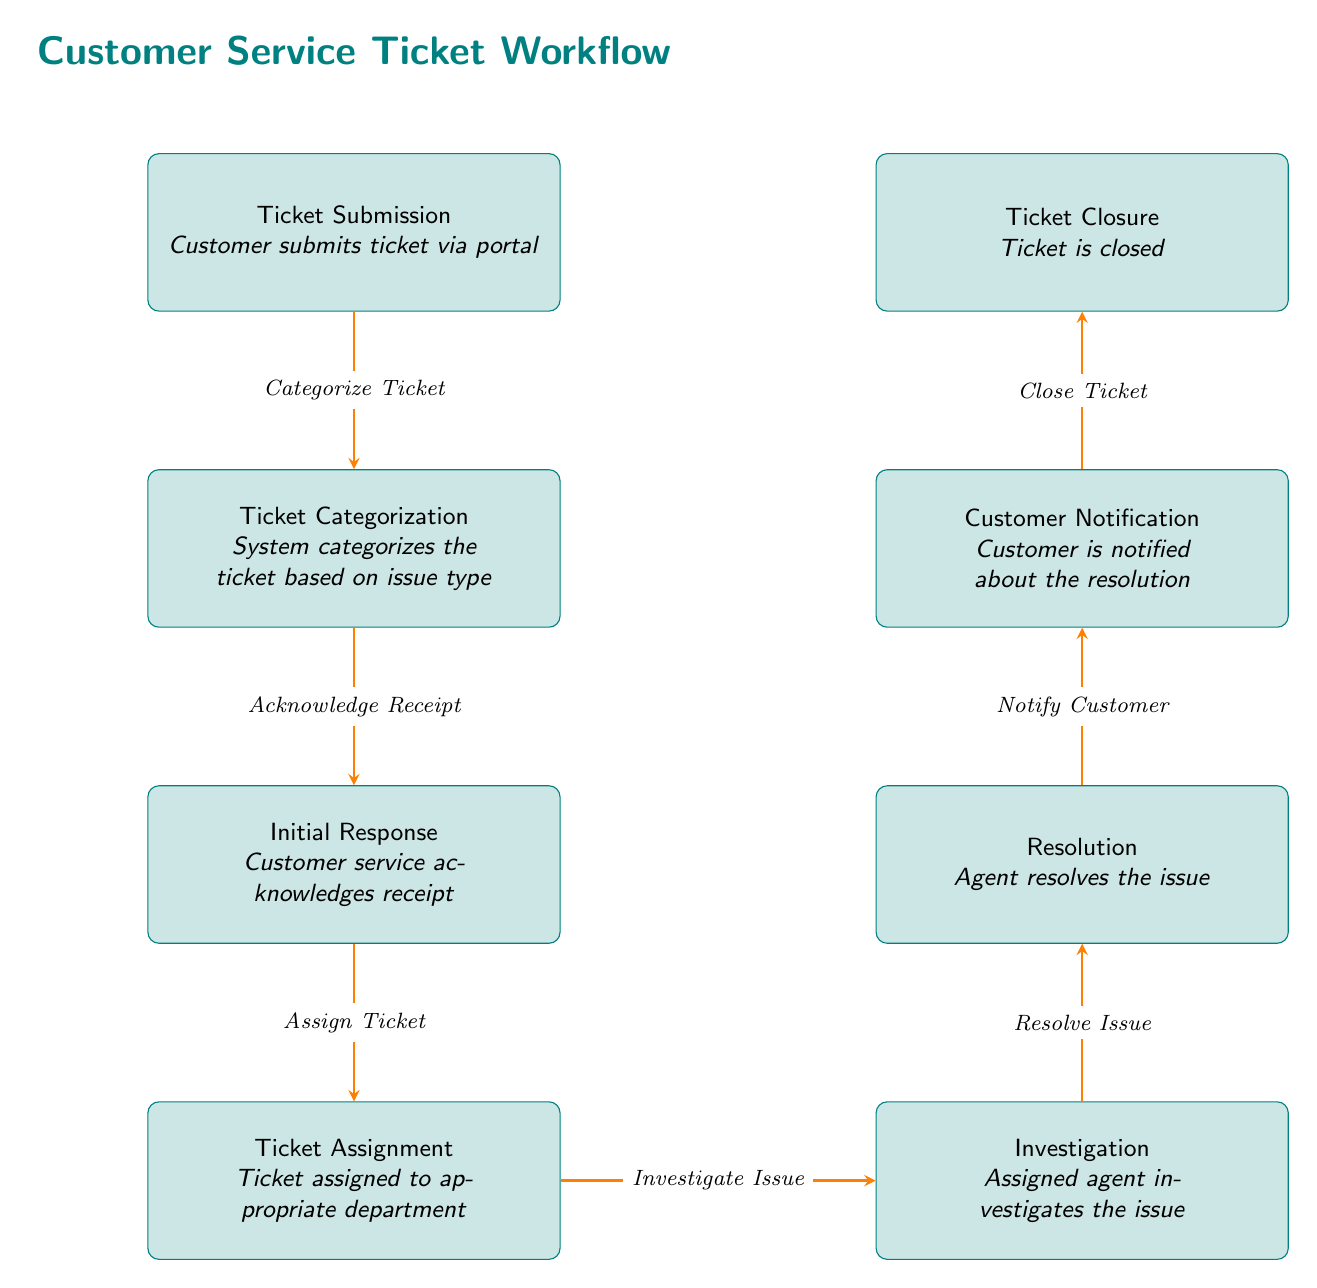What is the first step in the workflow? The first step, as shown in the diagram, is the "Ticket Submission". This is indicated as the topmost node in the diagram.
Answer: Ticket Submission How many nodes are there in total? By counting all the nodes in the diagram, we can identify that there are eight distinct nodes representing different stages of the ticket workflow.
Answer: 8 What action follows ticket categorization? The action that comes after "Ticket Categorization" is "Initial Response". This can be determined by looking at the directional arrow flowing from the categorization node to the response node.
Answer: Initial Response Which step occurs before customer notification? The step that occurs prior to "Customer Notification" in the workflow is "Resolution". We determine this by tracing the flow upwards from the notification node.
Answer: Resolution What is the last step in the process? The final step in the workflow is "Ticket Closure", which is the last node at the bottom of the diagram sequence.
Answer: Ticket Closure What action must occur after investigating the issue? The action that should follow "Investigation" is "Resolution". This is deduced by following the arrow from the investigation node to the resolution node in the diagram.
Answer: Resolution How many arrows are present in the diagram? By counting the arrows that represent actions between nodes, we find there are seven arrows connecting the eight nodes in the process.
Answer: 7 What is the role of the "Ticket Assignment" step? The function of the "Ticket Assignment" step is to assign the ticket to the appropriate department. This is described in the node text itself within the diagram.
Answer: Assign to department 